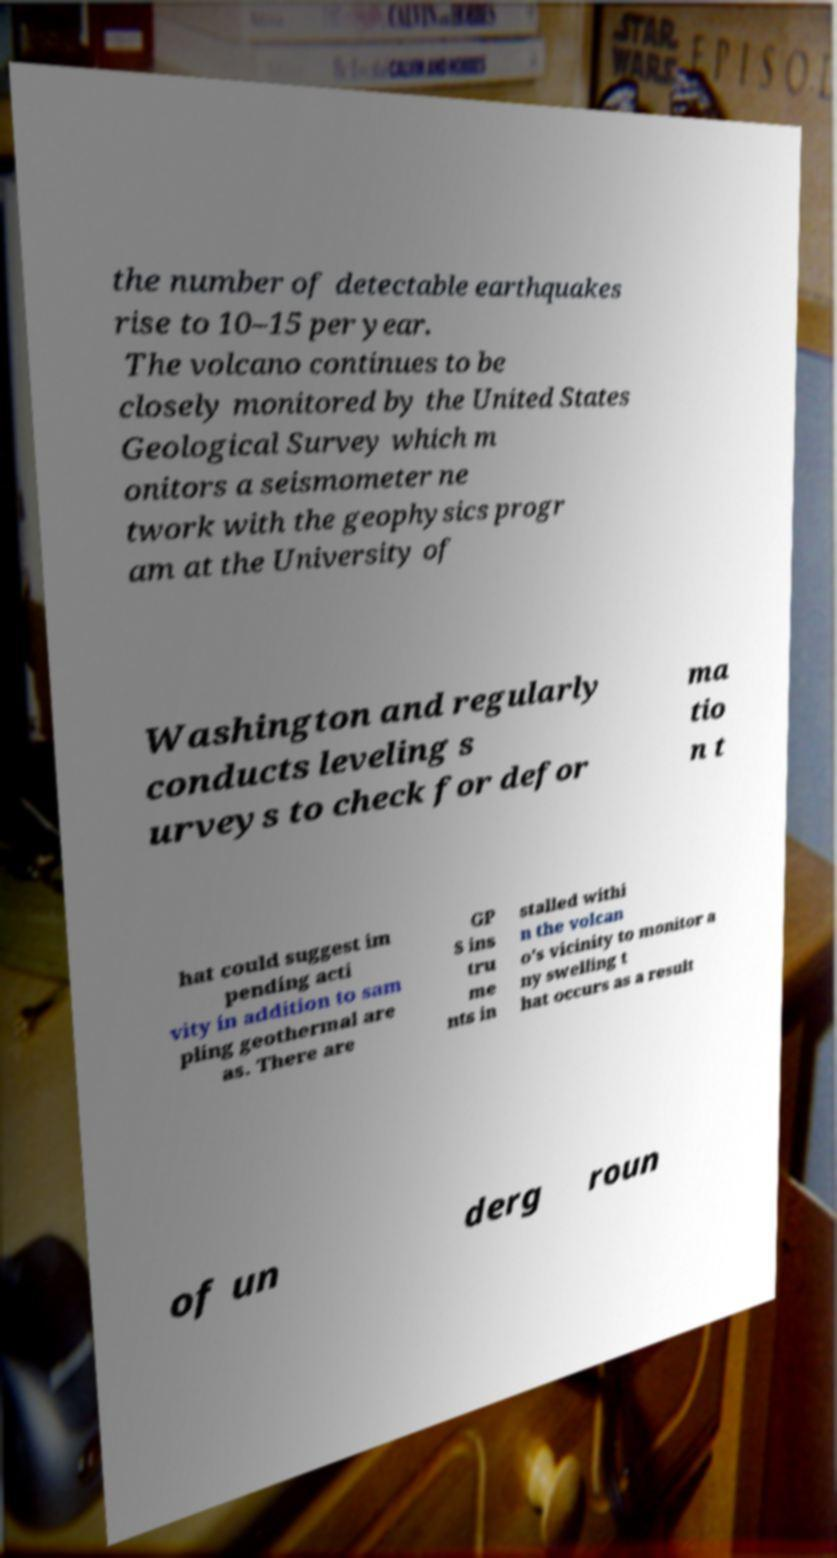Can you read and provide the text displayed in the image?This photo seems to have some interesting text. Can you extract and type it out for me? the number of detectable earthquakes rise to 10–15 per year. The volcano continues to be closely monitored by the United States Geological Survey which m onitors a seismometer ne twork with the geophysics progr am at the University of Washington and regularly conducts leveling s urveys to check for defor ma tio n t hat could suggest im pending acti vity in addition to sam pling geothermal are as. There are GP S ins tru me nts in stalled withi n the volcan o's vicinity to monitor a ny swelling t hat occurs as a result of un derg roun 